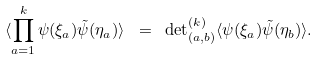<formula> <loc_0><loc_0><loc_500><loc_500>\langle \prod _ { a = 1 } ^ { k } \psi ( \xi _ { a } ) \tilde { \psi } ( \eta _ { a } ) \rangle \ = \ { \det } ^ { ( k ) } _ { ( a , b ) } \langle \psi ( \xi _ { a } ) \tilde { \psi } ( \eta _ { b } ) \rangle .</formula> 